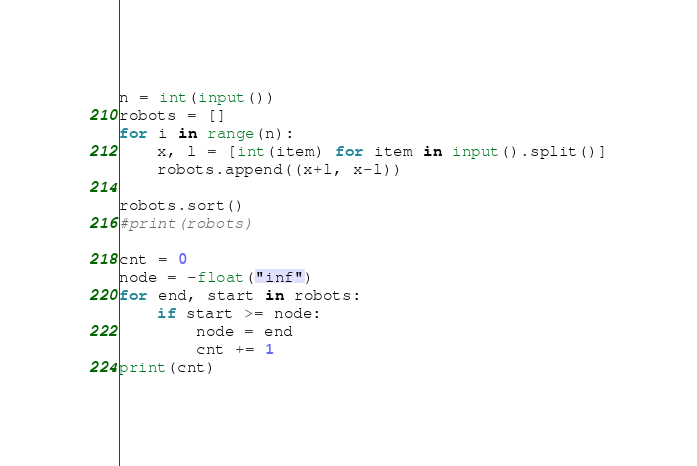Convert code to text. <code><loc_0><loc_0><loc_500><loc_500><_Python_>n = int(input())
robots = []
for i in range(n):
    x, l = [int(item) for item in input().split()]
    robots.append((x+l, x-l))
 
robots.sort()
#print(robots)

cnt = 0
node = -float("inf")
for end, start in robots:
    if start >= node:
        node = end
        cnt += 1
print(cnt)</code> 